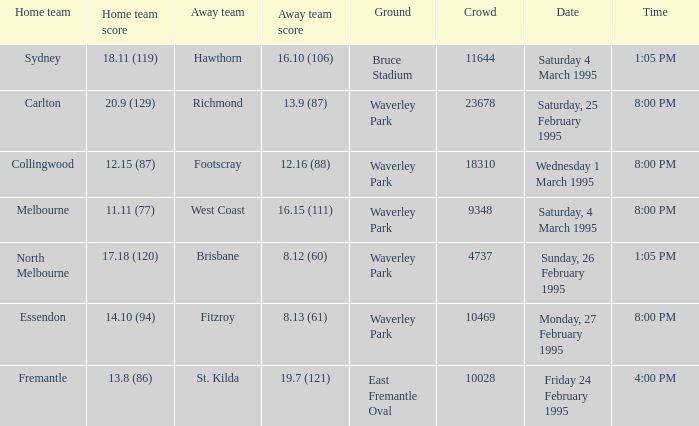Name the ground for essendon Waverley Park. Write the full table. {'header': ['Home team', 'Home team score', 'Away team', 'Away team score', 'Ground', 'Crowd', 'Date', 'Time'], 'rows': [['Sydney', '18.11 (119)', 'Hawthorn', '16.10 (106)', 'Bruce Stadium', '11644', 'Saturday 4 March 1995', '1:05 PM'], ['Carlton', '20.9 (129)', 'Richmond', '13.9 (87)', 'Waverley Park', '23678', 'Saturday, 25 February 1995', '8:00 PM'], ['Collingwood', '12.15 (87)', 'Footscray', '12.16 (88)', 'Waverley Park', '18310', 'Wednesday 1 March 1995', '8:00 PM'], ['Melbourne', '11.11 (77)', 'West Coast', '16.15 (111)', 'Waverley Park', '9348', 'Saturday, 4 March 1995', '8:00 PM'], ['North Melbourne', '17.18 (120)', 'Brisbane', '8.12 (60)', 'Waverley Park', '4737', 'Sunday, 26 February 1995', '1:05 PM'], ['Essendon', '14.10 (94)', 'Fitzroy', '8.13 (61)', 'Waverley Park', '10469', 'Monday, 27 February 1995', '8:00 PM'], ['Fremantle', '13.8 (86)', 'St. Kilda', '19.7 (121)', 'East Fremantle Oval', '10028', 'Friday 24 February 1995', '4:00 PM']]} 